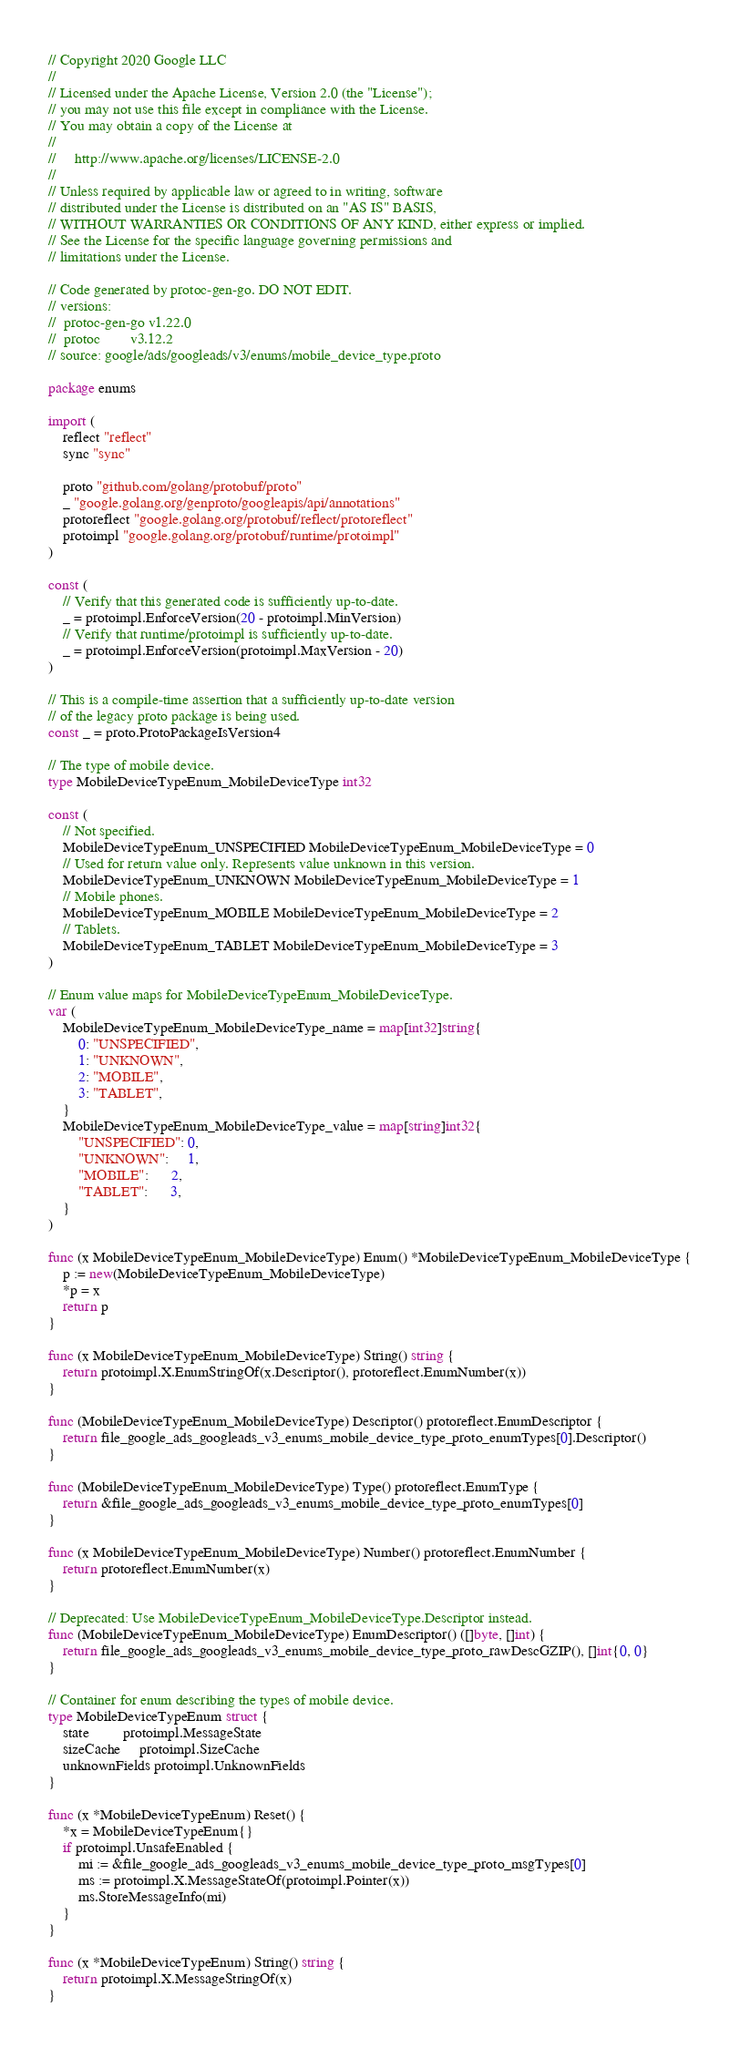Convert code to text. <code><loc_0><loc_0><loc_500><loc_500><_Go_>// Copyright 2020 Google LLC
//
// Licensed under the Apache License, Version 2.0 (the "License");
// you may not use this file except in compliance with the License.
// You may obtain a copy of the License at
//
//     http://www.apache.org/licenses/LICENSE-2.0
//
// Unless required by applicable law or agreed to in writing, software
// distributed under the License is distributed on an "AS IS" BASIS,
// WITHOUT WARRANTIES OR CONDITIONS OF ANY KIND, either express or implied.
// See the License for the specific language governing permissions and
// limitations under the License.

// Code generated by protoc-gen-go. DO NOT EDIT.
// versions:
// 	protoc-gen-go v1.22.0
// 	protoc        v3.12.2
// source: google/ads/googleads/v3/enums/mobile_device_type.proto

package enums

import (
	reflect "reflect"
	sync "sync"

	proto "github.com/golang/protobuf/proto"
	_ "google.golang.org/genproto/googleapis/api/annotations"
	protoreflect "google.golang.org/protobuf/reflect/protoreflect"
	protoimpl "google.golang.org/protobuf/runtime/protoimpl"
)

const (
	// Verify that this generated code is sufficiently up-to-date.
	_ = protoimpl.EnforceVersion(20 - protoimpl.MinVersion)
	// Verify that runtime/protoimpl is sufficiently up-to-date.
	_ = protoimpl.EnforceVersion(protoimpl.MaxVersion - 20)
)

// This is a compile-time assertion that a sufficiently up-to-date version
// of the legacy proto package is being used.
const _ = proto.ProtoPackageIsVersion4

// The type of mobile device.
type MobileDeviceTypeEnum_MobileDeviceType int32

const (
	// Not specified.
	MobileDeviceTypeEnum_UNSPECIFIED MobileDeviceTypeEnum_MobileDeviceType = 0
	// Used for return value only. Represents value unknown in this version.
	MobileDeviceTypeEnum_UNKNOWN MobileDeviceTypeEnum_MobileDeviceType = 1
	// Mobile phones.
	MobileDeviceTypeEnum_MOBILE MobileDeviceTypeEnum_MobileDeviceType = 2
	// Tablets.
	MobileDeviceTypeEnum_TABLET MobileDeviceTypeEnum_MobileDeviceType = 3
)

// Enum value maps for MobileDeviceTypeEnum_MobileDeviceType.
var (
	MobileDeviceTypeEnum_MobileDeviceType_name = map[int32]string{
		0: "UNSPECIFIED",
		1: "UNKNOWN",
		2: "MOBILE",
		3: "TABLET",
	}
	MobileDeviceTypeEnum_MobileDeviceType_value = map[string]int32{
		"UNSPECIFIED": 0,
		"UNKNOWN":     1,
		"MOBILE":      2,
		"TABLET":      3,
	}
)

func (x MobileDeviceTypeEnum_MobileDeviceType) Enum() *MobileDeviceTypeEnum_MobileDeviceType {
	p := new(MobileDeviceTypeEnum_MobileDeviceType)
	*p = x
	return p
}

func (x MobileDeviceTypeEnum_MobileDeviceType) String() string {
	return protoimpl.X.EnumStringOf(x.Descriptor(), protoreflect.EnumNumber(x))
}

func (MobileDeviceTypeEnum_MobileDeviceType) Descriptor() protoreflect.EnumDescriptor {
	return file_google_ads_googleads_v3_enums_mobile_device_type_proto_enumTypes[0].Descriptor()
}

func (MobileDeviceTypeEnum_MobileDeviceType) Type() protoreflect.EnumType {
	return &file_google_ads_googleads_v3_enums_mobile_device_type_proto_enumTypes[0]
}

func (x MobileDeviceTypeEnum_MobileDeviceType) Number() protoreflect.EnumNumber {
	return protoreflect.EnumNumber(x)
}

// Deprecated: Use MobileDeviceTypeEnum_MobileDeviceType.Descriptor instead.
func (MobileDeviceTypeEnum_MobileDeviceType) EnumDescriptor() ([]byte, []int) {
	return file_google_ads_googleads_v3_enums_mobile_device_type_proto_rawDescGZIP(), []int{0, 0}
}

// Container for enum describing the types of mobile device.
type MobileDeviceTypeEnum struct {
	state         protoimpl.MessageState
	sizeCache     protoimpl.SizeCache
	unknownFields protoimpl.UnknownFields
}

func (x *MobileDeviceTypeEnum) Reset() {
	*x = MobileDeviceTypeEnum{}
	if protoimpl.UnsafeEnabled {
		mi := &file_google_ads_googleads_v3_enums_mobile_device_type_proto_msgTypes[0]
		ms := protoimpl.X.MessageStateOf(protoimpl.Pointer(x))
		ms.StoreMessageInfo(mi)
	}
}

func (x *MobileDeviceTypeEnum) String() string {
	return protoimpl.X.MessageStringOf(x)
}
</code> 